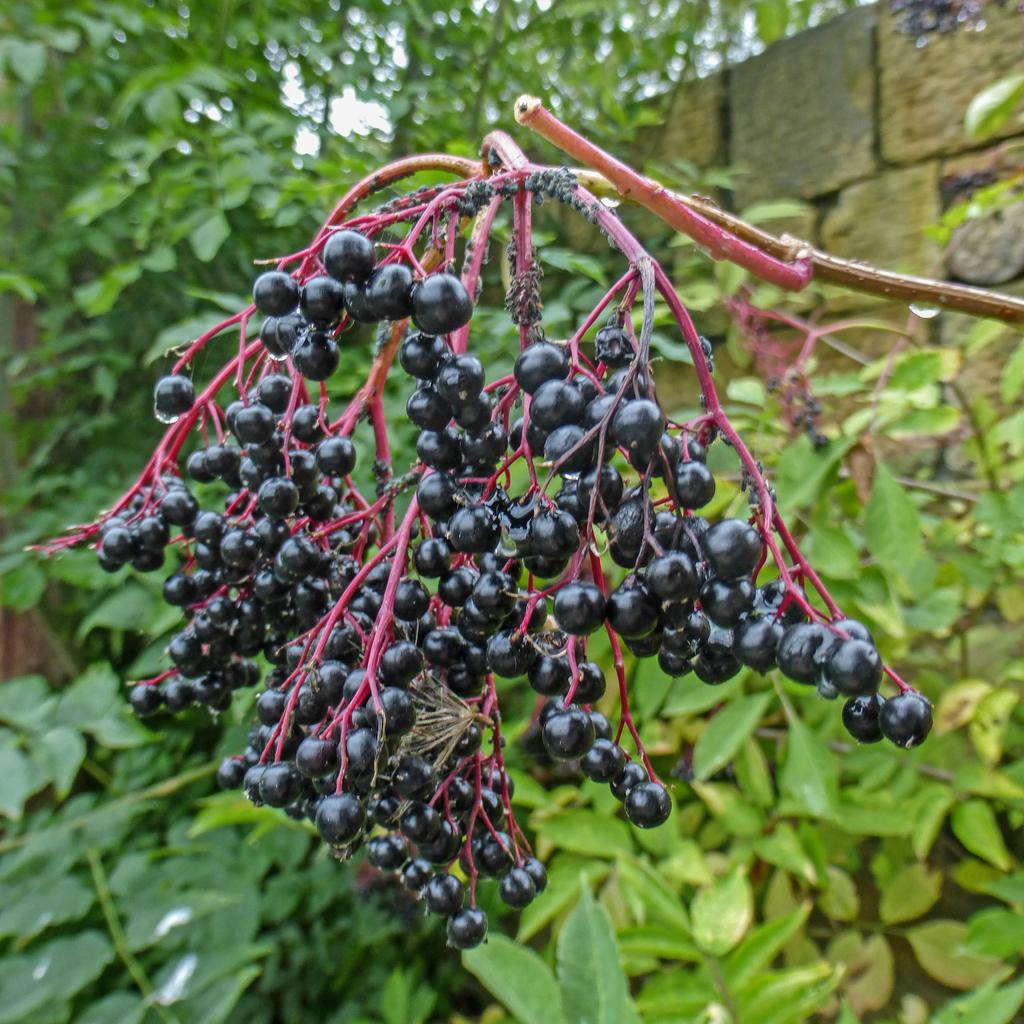What type of fruit can be seen on the tree in the image? There are berries on a tree in the image. What can be seen in the background of the image? There are trees and a wall visible in the background of the image. What type of grape is being sorted on the wall in the image? There is no grape or sorting activity present in the image; it features a tree with berries and trees and a wall in the background. 